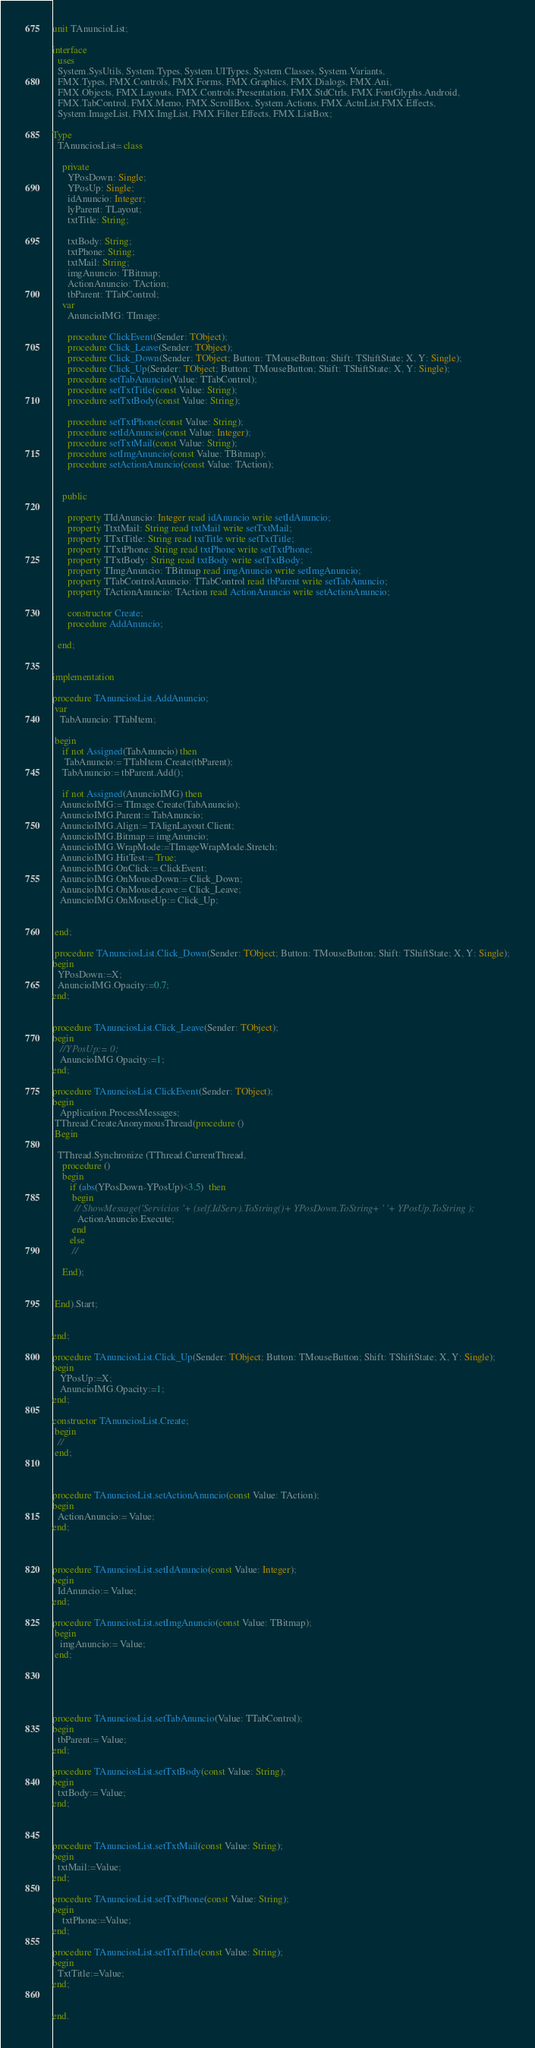Convert code to text. <code><loc_0><loc_0><loc_500><loc_500><_Pascal_>unit TAnuncioList;

interface
  uses
  System.SysUtils, System.Types, System.UITypes, System.Classes, System.Variants,
  FMX.Types, FMX.Controls, FMX.Forms, FMX.Graphics, FMX.Dialogs, FMX.Ani,
  FMX.Objects, FMX.Layouts, FMX.Controls.Presentation, FMX.StdCtrls, FMX.FontGlyphs.Android,
  FMX.TabControl, FMX.Memo, FMX.ScrollBox, System.Actions, FMX.ActnList,FMX.Effects,
  System.ImageList, FMX.ImgList, FMX.Filter.Effects, FMX.ListBox;

Type
  TAnunciosList= class

    private
      YPosDown: Single;
      YPosUp: Single;
      idAnuncio: Integer;
      lyParent: TLayout;
      txtTitle: String;

      txtBody: String;
      txtPhone: String;
      txtMail: String;
      imgAnuncio: TBitmap;
      ActionAnuncio: TAction;
      tbParent: TTabControl;
    var
      AnuncioIMG: TImage;

      procedure ClickEvent(Sender: TObject);
      procedure Click_Leave(Sender: TObject);
      procedure Click_Down(Sender: TObject; Button: TMouseButton; Shift: TShiftState; X, Y: Single);
      procedure Click_Up(Sender: TObject; Button: TMouseButton; Shift: TShiftState; X, Y: Single);
      procedure setTabAnuncio(Value: TTabControl);
      procedure setTxtTitle(const Value: String);
      procedure setTxtBody(const Value: String);

      procedure setTxtPhone(const Value: String);
      procedure setIdAnuncio(const Value: Integer);
      procedure setTxtMail(const Value: String);
      procedure setImgAnuncio(const Value: TBitmap);
      procedure setActionAnuncio(const Value: TAction);


    public

      property TIdAnuncio: Integer read idAnuncio write setIdAnuncio;
      property TtxtMail: String read txtMail write setTxtMail;
      property TTxtTitle: String read txtTitle write setTxtTitle;
      property TTxtPhone: String read txtPhone write setTxtPhone;
      property TTxtBody: String read txtBody write setTxtBody;
      property TImgAnuncio: TBitmap read imgAnuncio write setImgAnuncio;
      property TTabControlAnuncio: TTabControl read tbParent write setTabAnuncio;
      property TActionAnuncio: TAction read ActionAnuncio write setActionAnuncio;

      constructor Create;
      procedure AddAnuncio;

  end;


implementation

procedure TAnunciosList.AddAnuncio;
 var
   TabAnuncio: TTabItem;

 begin
    if not Assigned(TabAnuncio) then
     TabAnuncio:= TTabItem.Create(tbParent);
    TabAnuncio:= tbParent.Add();

    if not Assigned(AnuncioIMG) then
   AnuncioIMG:= TImage.Create(TabAnuncio);
   AnuncioIMG.Parent:= TabAnuncio;
   AnuncioIMG.Align:= TAlignLayout.Client;
   AnuncioIMG.Bitmap:= imgAnuncio;
   AnuncioIMG.WrapMode:=TImageWrapMode.Stretch;
   AnuncioIMG.HitTest:= True;
   AnuncioIMG.OnClick:= ClickEvent;
   AnuncioIMG.OnMouseDown:= Click_Down;
   AnuncioIMG.OnMouseLeave:= Click_Leave;
   AnuncioIMG.OnMouseUp:= Click_Up;


 end;

 procedure TAnunciosList.Click_Down(Sender: TObject; Button: TMouseButton; Shift: TShiftState; X, Y: Single);
begin
  YPosDown:=X;
  AnuncioIMG.Opacity:=0.7;
end;


procedure TAnunciosList.Click_Leave(Sender: TObject);
begin
   //YPosUp:= 0;
   AnuncioIMG.Opacity:=1;
end;

procedure TAnunciosList.ClickEvent(Sender: TObject);
begin
   Application.ProcessMessages;
 TThread.CreateAnonymousThread(procedure ()
 Begin

  TThread.Synchronize (TThread.CurrentThread,
    procedure ()
    begin
       if (abs(YPosDown-YPosUp)<3.5)  then
        begin
         // ShowMessage('Servicios '+ (self.IdServ).ToString()+ YPosDown.ToString+ ' '+ YPosUp.ToString );
          ActionAnuncio.Execute;
        end
       else
        //

    End);


 End).Start;


end;

procedure TAnunciosList.Click_Up(Sender: TObject; Button: TMouseButton; Shift: TShiftState; X, Y: Single);
begin
   YPosUp:=X;
   AnuncioIMG.Opacity:=1;
end;

constructor TAnunciosList.Create;
 begin
  //
 end;



procedure TAnunciosList.setActionAnuncio(const Value: TAction);
begin
  ActionAnuncio:= Value;
end;



procedure TAnunciosList.setIdAnuncio(const Value: Integer);
begin
  IdAnuncio:= Value;
end;

procedure TAnunciosList.setImgAnuncio(const Value: TBitmap);
 begin
   imgAnuncio:= Value;
 end;





procedure TAnunciosList.setTabAnuncio(Value: TTabControl);
begin
  tbParent:= Value;
end;

procedure TAnunciosList.setTxtBody(const Value: String);
begin
  txtBody:= Value;
end;



procedure TAnunciosList.setTxtMail(const Value: String);
begin
  txtMail:=Value;
end;

procedure TAnunciosList.setTxtPhone(const Value: String);
begin
    txtPhone:=Value;
end;

procedure TAnunciosList.setTxtTitle(const Value: String);
begin
  TxtTitle:=Value;
end;


end.
</code> 